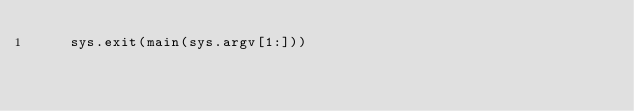Convert code to text. <code><loc_0><loc_0><loc_500><loc_500><_Python_>    sys.exit(main(sys.argv[1:]))
</code> 